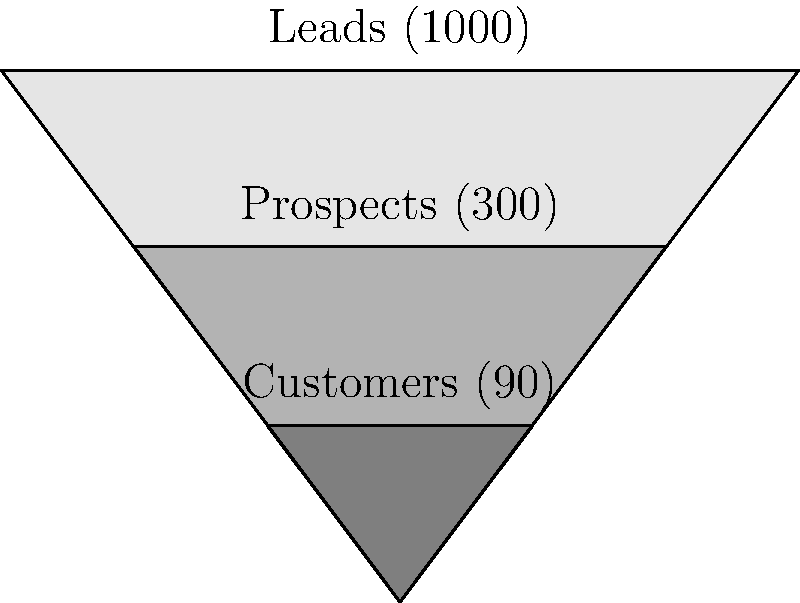Given the sales funnel pyramid chart above, what is the overall conversion rate from leads to customers, and how can this information be used to optimize the sales process? To calculate the overall conversion rate and understand how to optimize the sales process, let's follow these steps:

1. Identify the numbers at each stage of the funnel:
   - Leads: 1000
   - Prospects: 300
   - Customers: 90

2. Calculate the overall conversion rate:
   Overall conversion rate = (Number of Customers / Number of Leads) × 100%
   $$ \text{Overall conversion rate} = \frac{90}{1000} \times 100\% = 9\% $$

3. Calculate intermediate conversion rates:
   - Leads to Prospects: $(300 / 1000) \times 100\% = 30\%$
   - Prospects to Customers: $(90 / 300) \times 100\% = 30\%$

4. Analyze the funnel:
   The overall conversion rate of 9% indicates that there's room for improvement in the sales process. The equal conversion rates of 30% at each stage suggest that efforts should be made to improve both stages of the funnel.

5. Optimize the sales process:
   a. Improve lead quality: Focus on attracting more qualified leads to increase the lead-to-prospect conversion rate.
   b. Enhance prospect nurturing: Develop better strategies to convert prospects into customers, such as personalized follow-ups or targeted content.
   c. Implement A/B testing: Test different approaches at each stage to identify the most effective tactics.
   d. Provide sales team training: Equip the sales team with skills to better qualify leads and close deals.
   e. Utilize marketing automation: Implement tools to nurture leads and prospects more efficiently.
   f. Analyze drop-off points: Identify where potential customers are leaving the funnel and address those pain points.

By focusing on these optimization strategies, the company can work towards improving the overall conversion rate and increasing business revenues.
Answer: 9% overall conversion rate; optimize by improving lead quality, enhancing prospect nurturing, A/B testing, sales training, marketing automation, and analyzing drop-off points. 